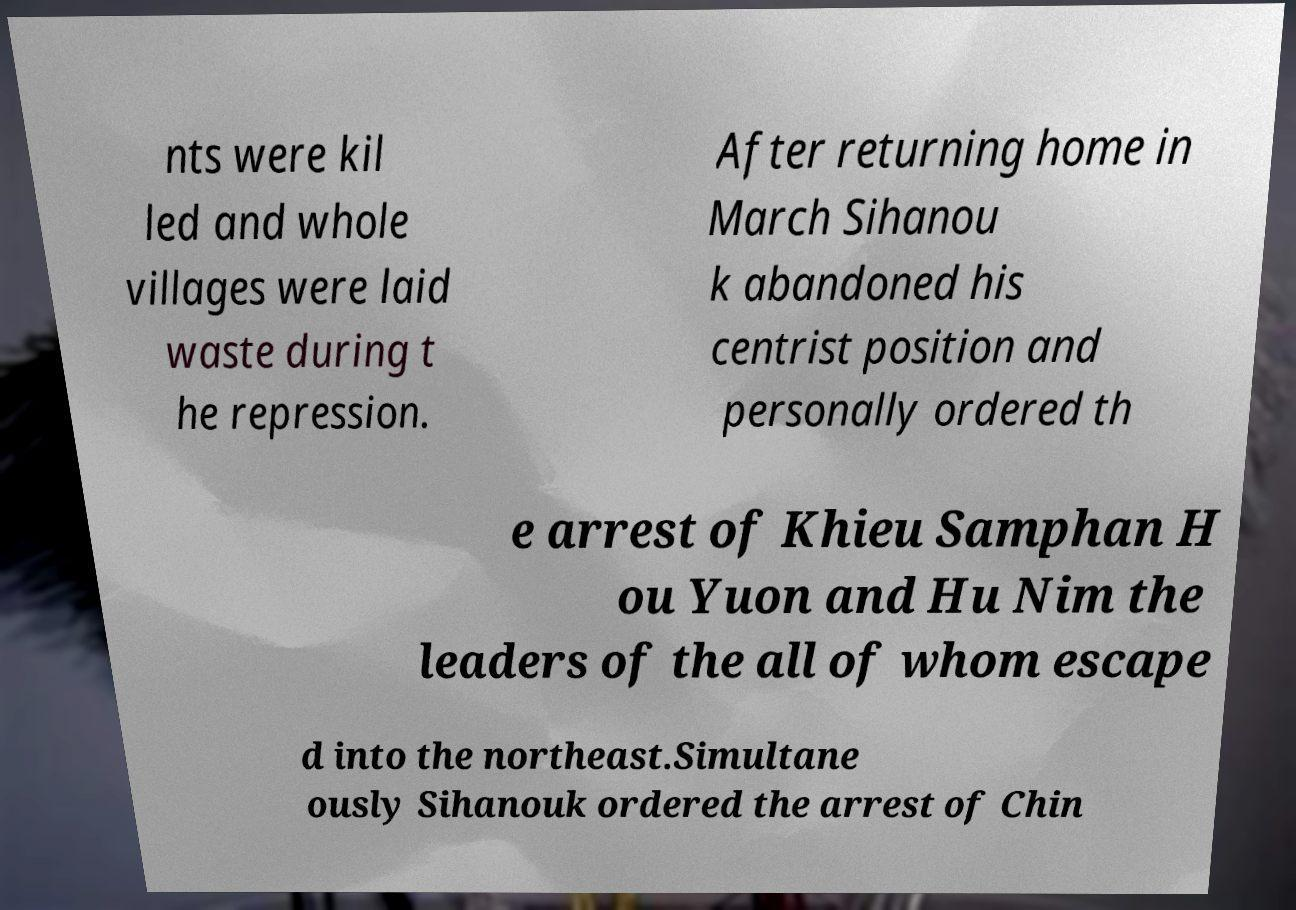Can you read and provide the text displayed in the image?This photo seems to have some interesting text. Can you extract and type it out for me? nts were kil led and whole villages were laid waste during t he repression. After returning home in March Sihanou k abandoned his centrist position and personally ordered th e arrest of Khieu Samphan H ou Yuon and Hu Nim the leaders of the all of whom escape d into the northeast.Simultane ously Sihanouk ordered the arrest of Chin 